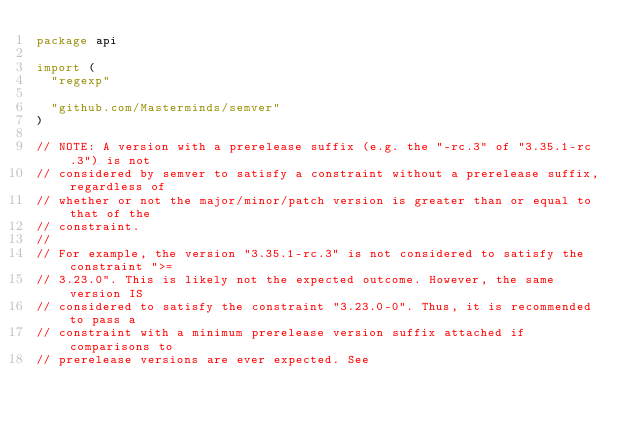<code> <loc_0><loc_0><loc_500><loc_500><_Go_>package api

import (
	"regexp"

	"github.com/Masterminds/semver"
)

// NOTE: A version with a prerelease suffix (e.g. the "-rc.3" of "3.35.1-rc.3") is not
// considered by semver to satisfy a constraint without a prerelease suffix, regardless of
// whether or not the major/minor/patch version is greater than or equal to that of the
// constraint.
//
// For example, the version "3.35.1-rc.3" is not considered to satisfy the constraint ">=
// 3.23.0". This is likely not the expected outcome. However, the same version IS
// considered to satisfy the constraint "3.23.0-0". Thus, it is recommended to pass a
// constraint with a minimum prerelease version suffix attached if comparisons to
// prerelease versions are ever expected. See</code> 